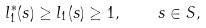<formula> <loc_0><loc_0><loc_500><loc_500>l ^ { * } _ { 1 } ( s ) \geq l _ { 1 } ( s ) \geq 1 , \quad s \in S ,</formula> 